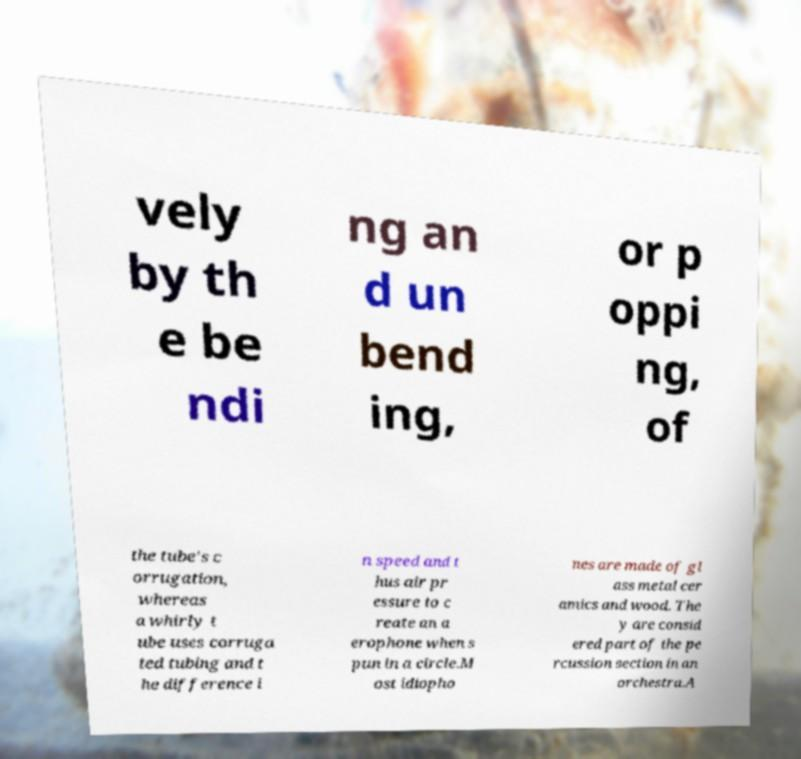For documentation purposes, I need the text within this image transcribed. Could you provide that? vely by th e be ndi ng an d un bend ing, or p oppi ng, of the tube's c orrugation, whereas a whirly t ube uses corruga ted tubing and t he difference i n speed and t hus air pr essure to c reate an a erophone when s pun in a circle.M ost idiopho nes are made of gl ass metal cer amics and wood. The y are consid ered part of the pe rcussion section in an orchestra.A 